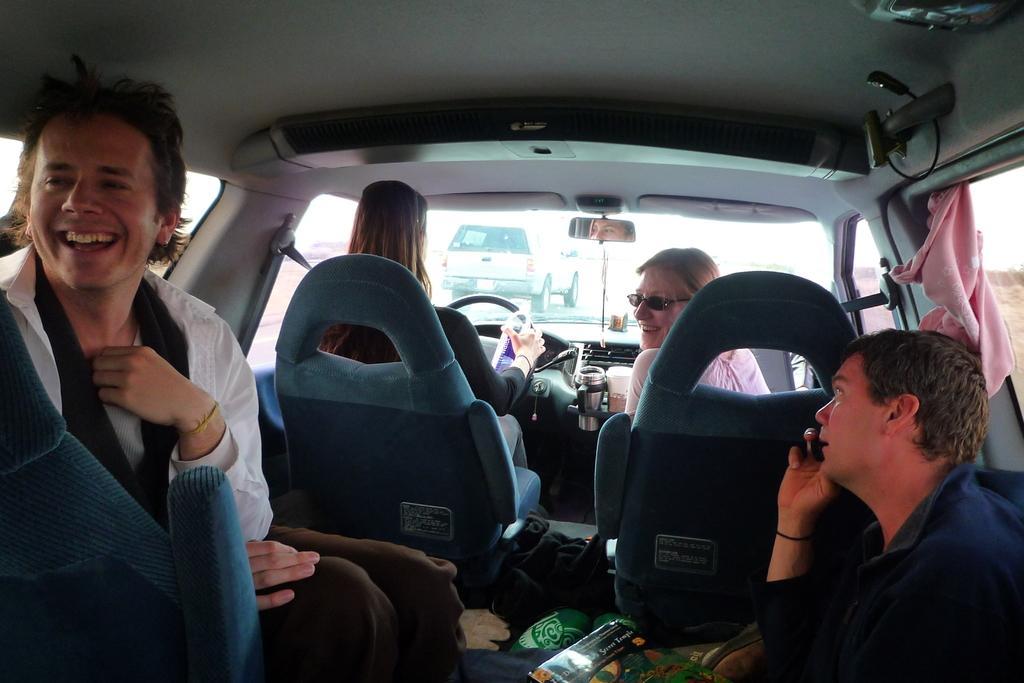Could you give a brief overview of what you see in this image? In this image we can see four persons sitting inside a car. On the right side of the image there is a man sitting and holding a mobile phone in his hands. In the front room of the car there are two women sitting. In the background of the image we can see another car through the windshield. 